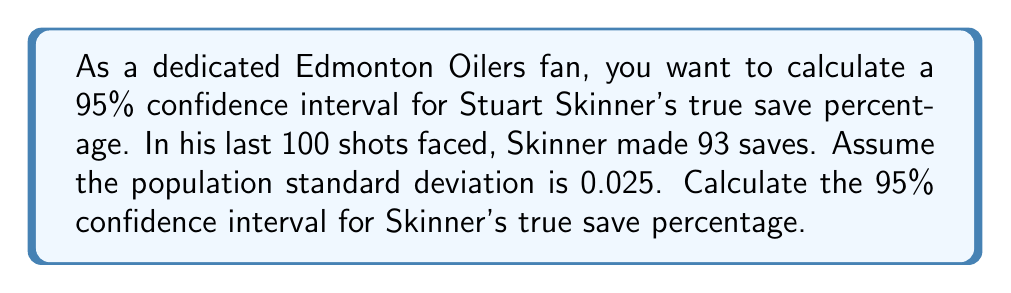Give your solution to this math problem. Let's approach this step-by-step:

1) First, we need to identify the key information:
   - Sample size (n) = 100 shots
   - Sample proportion (p̂) = 93/100 = 0.93
   - Population standard deviation (σ) = 0.025
   - Confidence level = 95% (z-score = 1.96)

2) The formula for the confidence interval is:

   $$\text{CI} = \hat{p} \pm z \cdot \frac{\sigma}{\sqrt{n}}$$

3) Let's substitute our values:

   $$\text{CI} = 0.93 \pm 1.96 \cdot \frac{0.025}{\sqrt{100}}$$

4) Simplify the square root:

   $$\text{CI} = 0.93 \pm 1.96 \cdot \frac{0.025}{10}$$

5) Calculate the margin of error:

   $$\text{Margin of Error} = 1.96 \cdot 0.0025 = 0.0049$$

6) Now, we can calculate the lower and upper bounds:

   Lower bound: $0.93 - 0.0049 = 0.9251$
   Upper bound: $0.93 + 0.0049 = 0.9349$

7) Therefore, we're 95% confident that Stuart Skinner's true save percentage falls between 0.9251 and 0.9349, or between 92.51% and 93.49%.
Answer: (0.9251, 0.9349) 